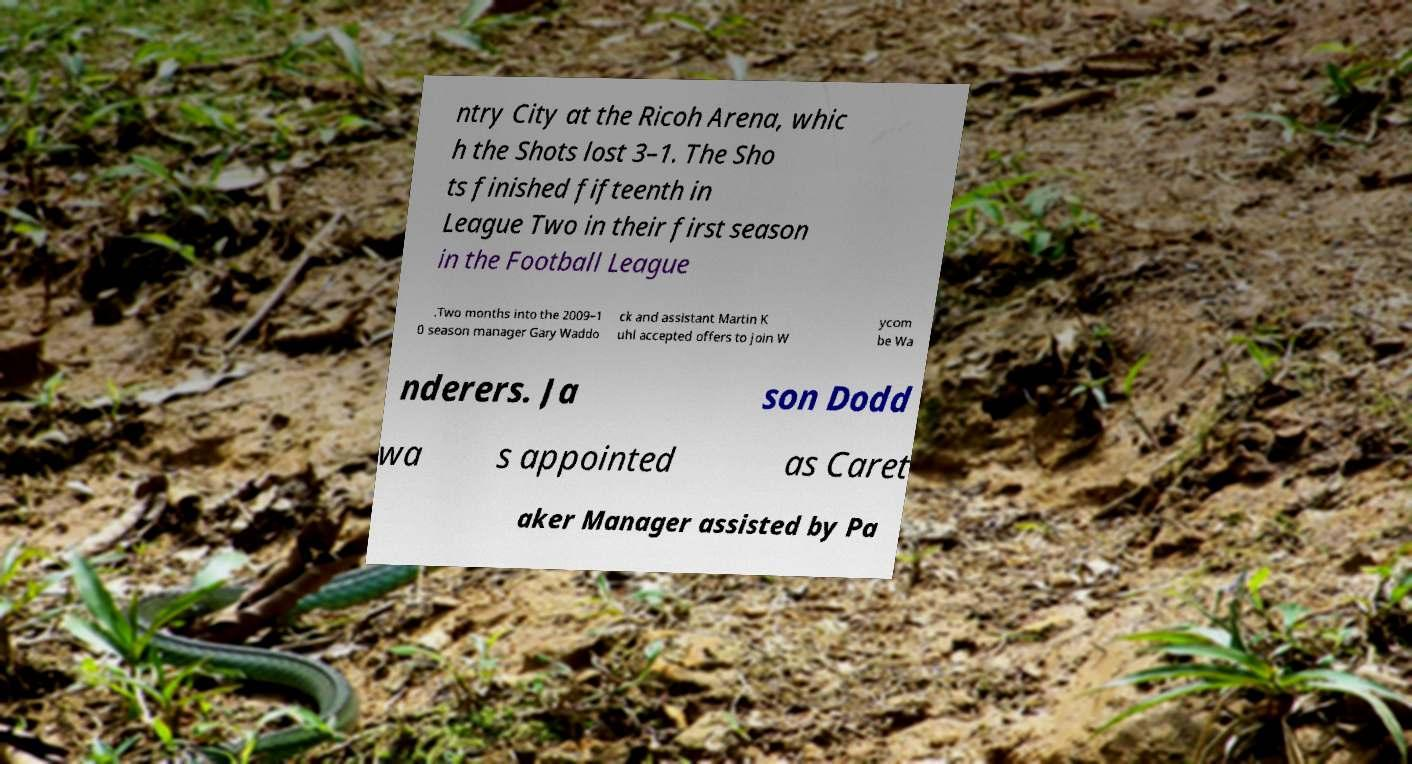I need the written content from this picture converted into text. Can you do that? ntry City at the Ricoh Arena, whic h the Shots lost 3–1. The Sho ts finished fifteenth in League Two in their first season in the Football League .Two months into the 2009–1 0 season manager Gary Waddo ck and assistant Martin K uhl accepted offers to join W ycom be Wa nderers. Ja son Dodd wa s appointed as Caret aker Manager assisted by Pa 